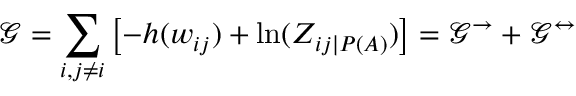Convert formula to latex. <formula><loc_0><loc_0><loc_500><loc_500>\mathcal { G } = \sum _ { i , j \neq i } \left [ - h ( w _ { i j } ) + \ln ( Z _ { i j | P ( A ) } ) \right ] = \mathcal { G } ^ { \rightarrow } + \mathcal { G } ^ { \leftrightarrow }</formula> 